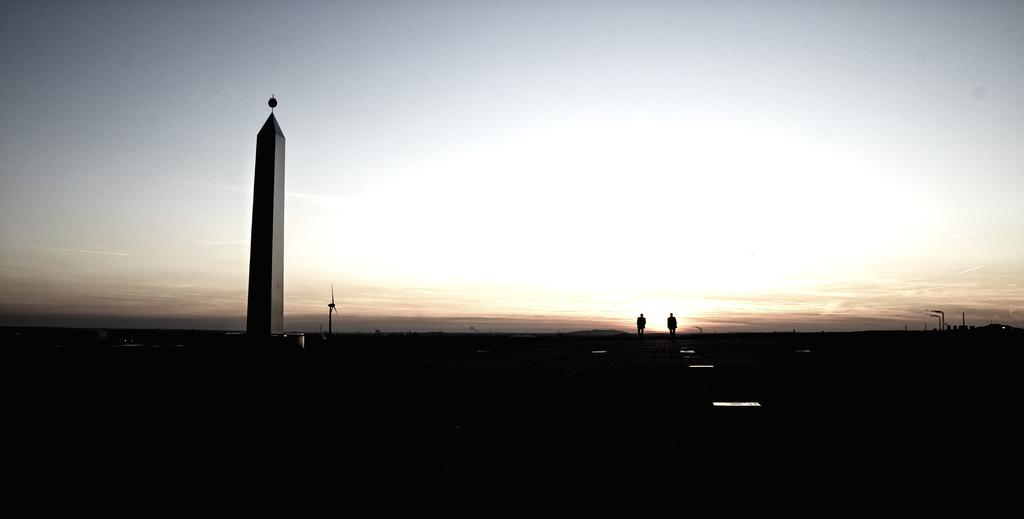What is the main structure in the image? There is a tower in the image. What architectural features can be seen in the image? There are pillars in the image. Can you describe the people in the image? There are two persons on the road in the image. What type of buildings are present in the image? There are houses in the image. What is visible in the background of the image? The sky is visible in the image. Can you determine the time of day the image was taken? The image may have been taken during the night, as there is no visible sunlight. What type of popcorn is being served at the pig farm in the image? There is no popcorn or pig farm present in the image. How is the connection between the two persons on the road established in the image? The image does not show any direct connection between the two persons on the road. 